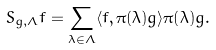<formula> <loc_0><loc_0><loc_500><loc_500>S _ { g , \Lambda } f = \sum _ { \lambda \in \Lambda } \langle f , \pi ( \lambda ) g \rangle \pi ( \lambda ) g .</formula> 